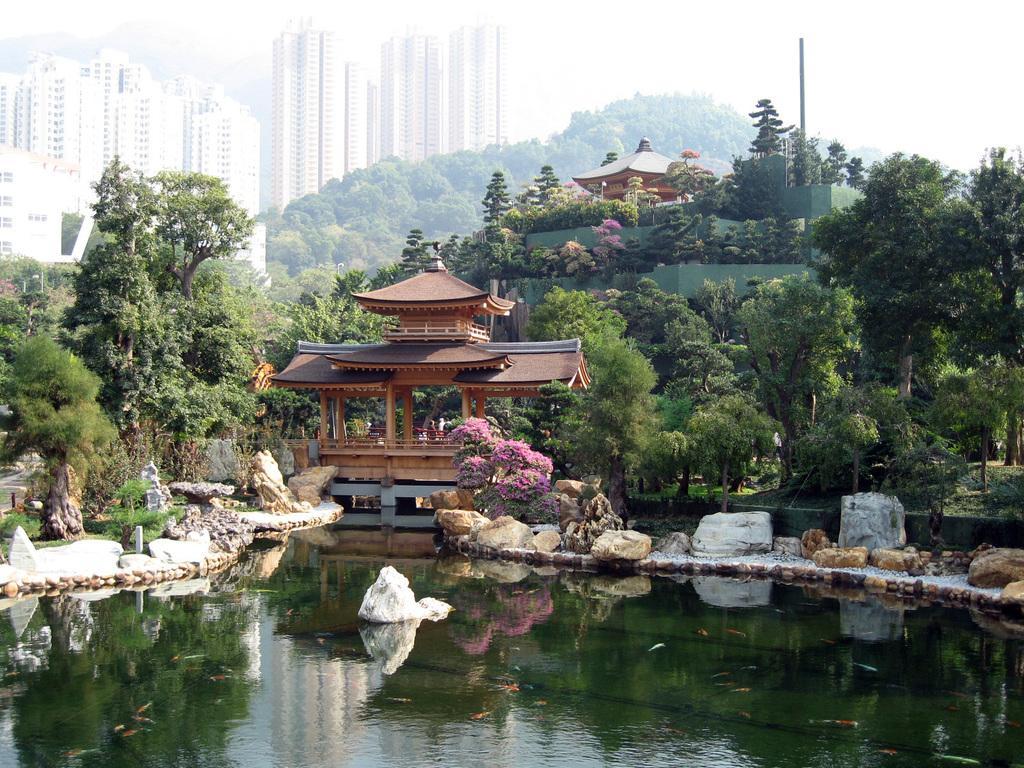In one or two sentences, can you explain what this image depicts? In this image there is a pond, on either side of the pond there are rocks, in the background there is an architecture and trees and buildings. 